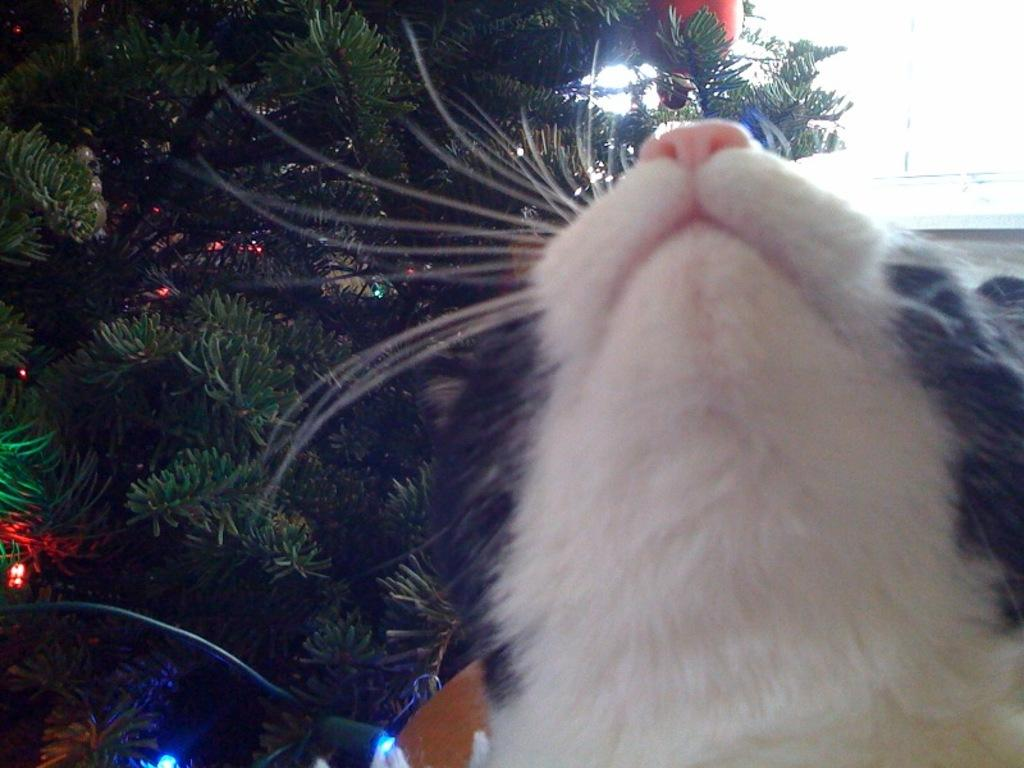What type of animal is in the image? There is a cat in the image. What other objects or features can be seen in the image? There are trees and a light visible in the image. What part of the natural environment is visible in the image? The sky is visible in the image. What type of linen is draped over the cat in the image? There is no linen present in the image, and the cat is not draped with any fabric. 